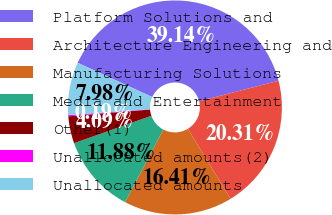Convert chart. <chart><loc_0><loc_0><loc_500><loc_500><pie_chart><fcel>Platform Solutions and<fcel>Architecture Engineering and<fcel>Manufacturing Solutions<fcel>Media and Entertainment<fcel>Other(1)<fcel>Unallocated amounts(2)<fcel>Unallocated amounts<nl><fcel>39.14%<fcel>20.31%<fcel>16.41%<fcel>11.88%<fcel>4.09%<fcel>0.19%<fcel>7.98%<nl></chart> 